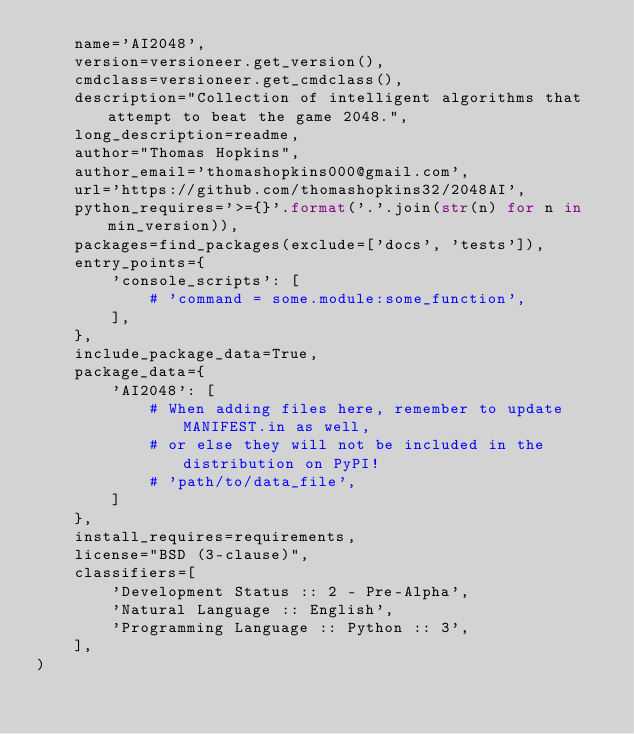Convert code to text. <code><loc_0><loc_0><loc_500><loc_500><_Python_>    name='AI2048',
    version=versioneer.get_version(),
    cmdclass=versioneer.get_cmdclass(),
    description="Collection of intelligent algorithms that attempt to beat the game 2048.",
    long_description=readme,
    author="Thomas Hopkins",
    author_email='thomashopkins000@gmail.com',
    url='https://github.com/thomashopkins32/2048AI',
    python_requires='>={}'.format('.'.join(str(n) for n in min_version)),
    packages=find_packages(exclude=['docs', 'tests']),
    entry_points={
        'console_scripts': [
            # 'command = some.module:some_function',
        ],
    },
    include_package_data=True,
    package_data={
        'AI2048': [
            # When adding files here, remember to update MANIFEST.in as well,
            # or else they will not be included in the distribution on PyPI!
            # 'path/to/data_file',
        ]
    },
    install_requires=requirements,
    license="BSD (3-clause)",
    classifiers=[
        'Development Status :: 2 - Pre-Alpha',
        'Natural Language :: English',
        'Programming Language :: Python :: 3',
    ],
)
</code> 